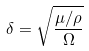Convert formula to latex. <formula><loc_0><loc_0><loc_500><loc_500>\delta = \sqrt { \frac { \mu / \rho } { \Omega } }</formula> 